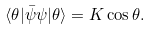Convert formula to latex. <formula><loc_0><loc_0><loc_500><loc_500>\langle \theta | \bar { \psi } \psi | \theta \rangle = K \cos \theta .</formula> 